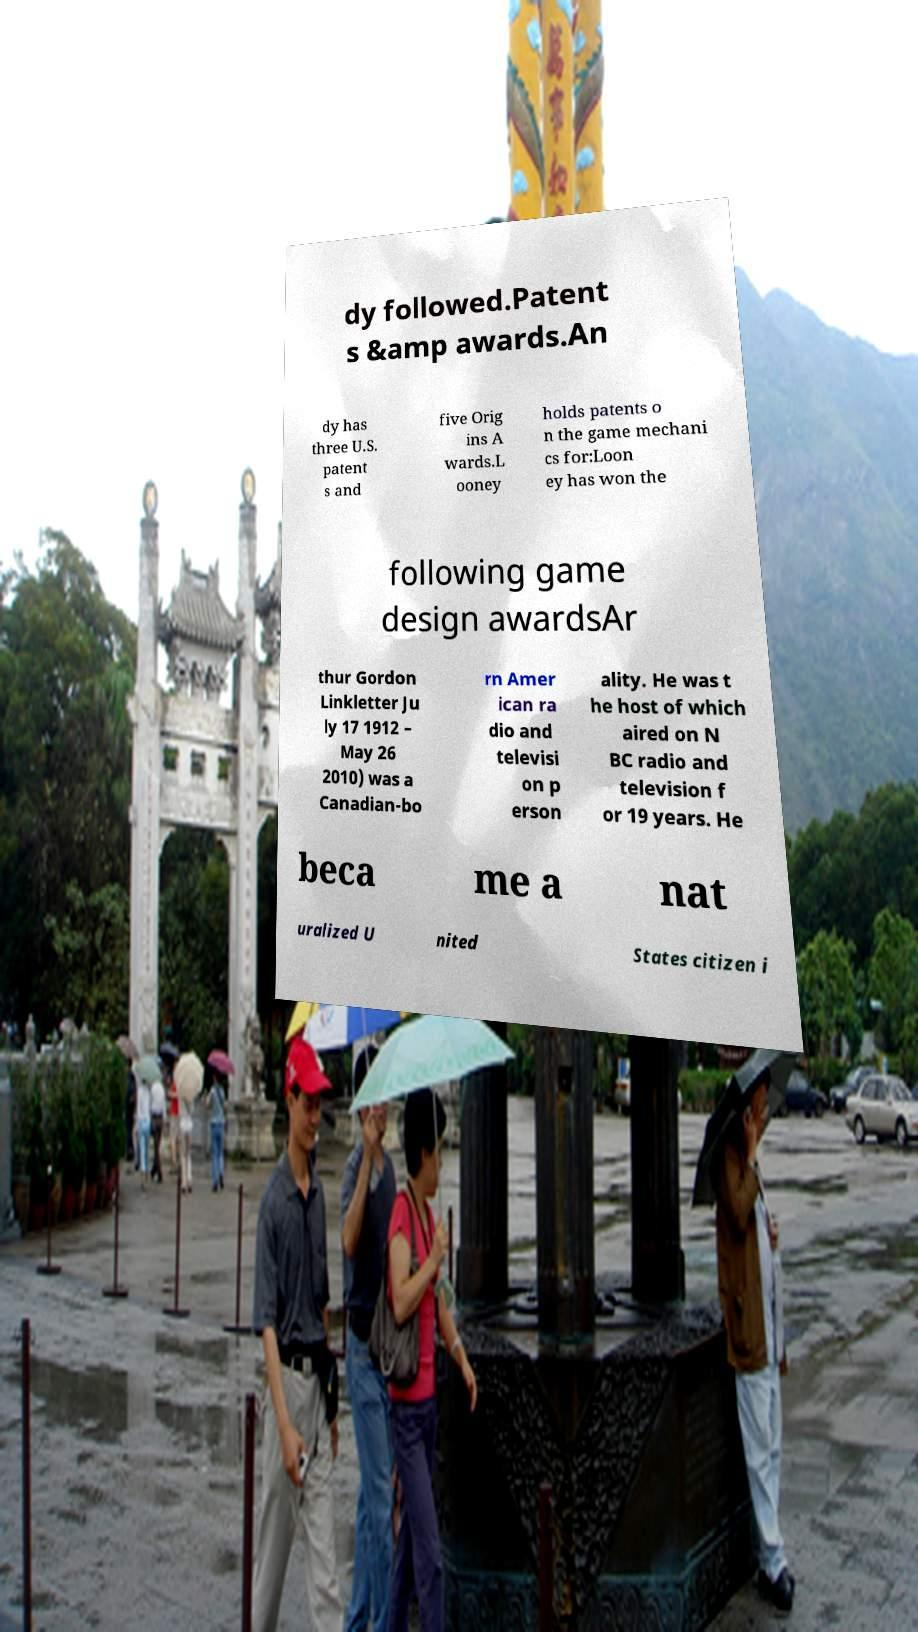For documentation purposes, I need the text within this image transcribed. Could you provide that? dy followed.Patent s &amp awards.An dy has three U.S. patent s and five Orig ins A wards.L ooney holds patents o n the game mechani cs for:Loon ey has won the following game design awardsAr thur Gordon Linkletter Ju ly 17 1912 – May 26 2010) was a Canadian-bo rn Amer ican ra dio and televisi on p erson ality. He was t he host of which aired on N BC radio and television f or 19 years. He beca me a nat uralized U nited States citizen i 